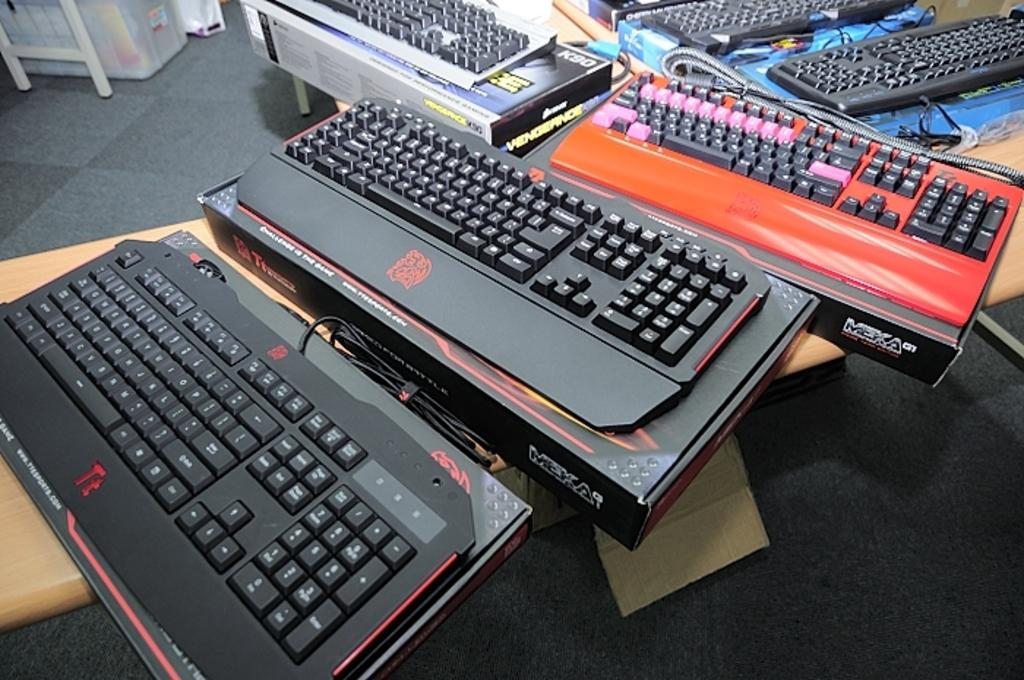What types of objects are present in the image? There are different kinds of boards, cables, and boxes in the image. Where are these objects located? The boards, cables, and boxes are on objects in the image. What type of eggnog is being used to lubricate the wrench in the image? There is no wrench or eggnog present in the image. Is the carpenter in the image using a specific tool to work on the boards? The image does not show a carpenter or any specific tools being used to work on the boards. 